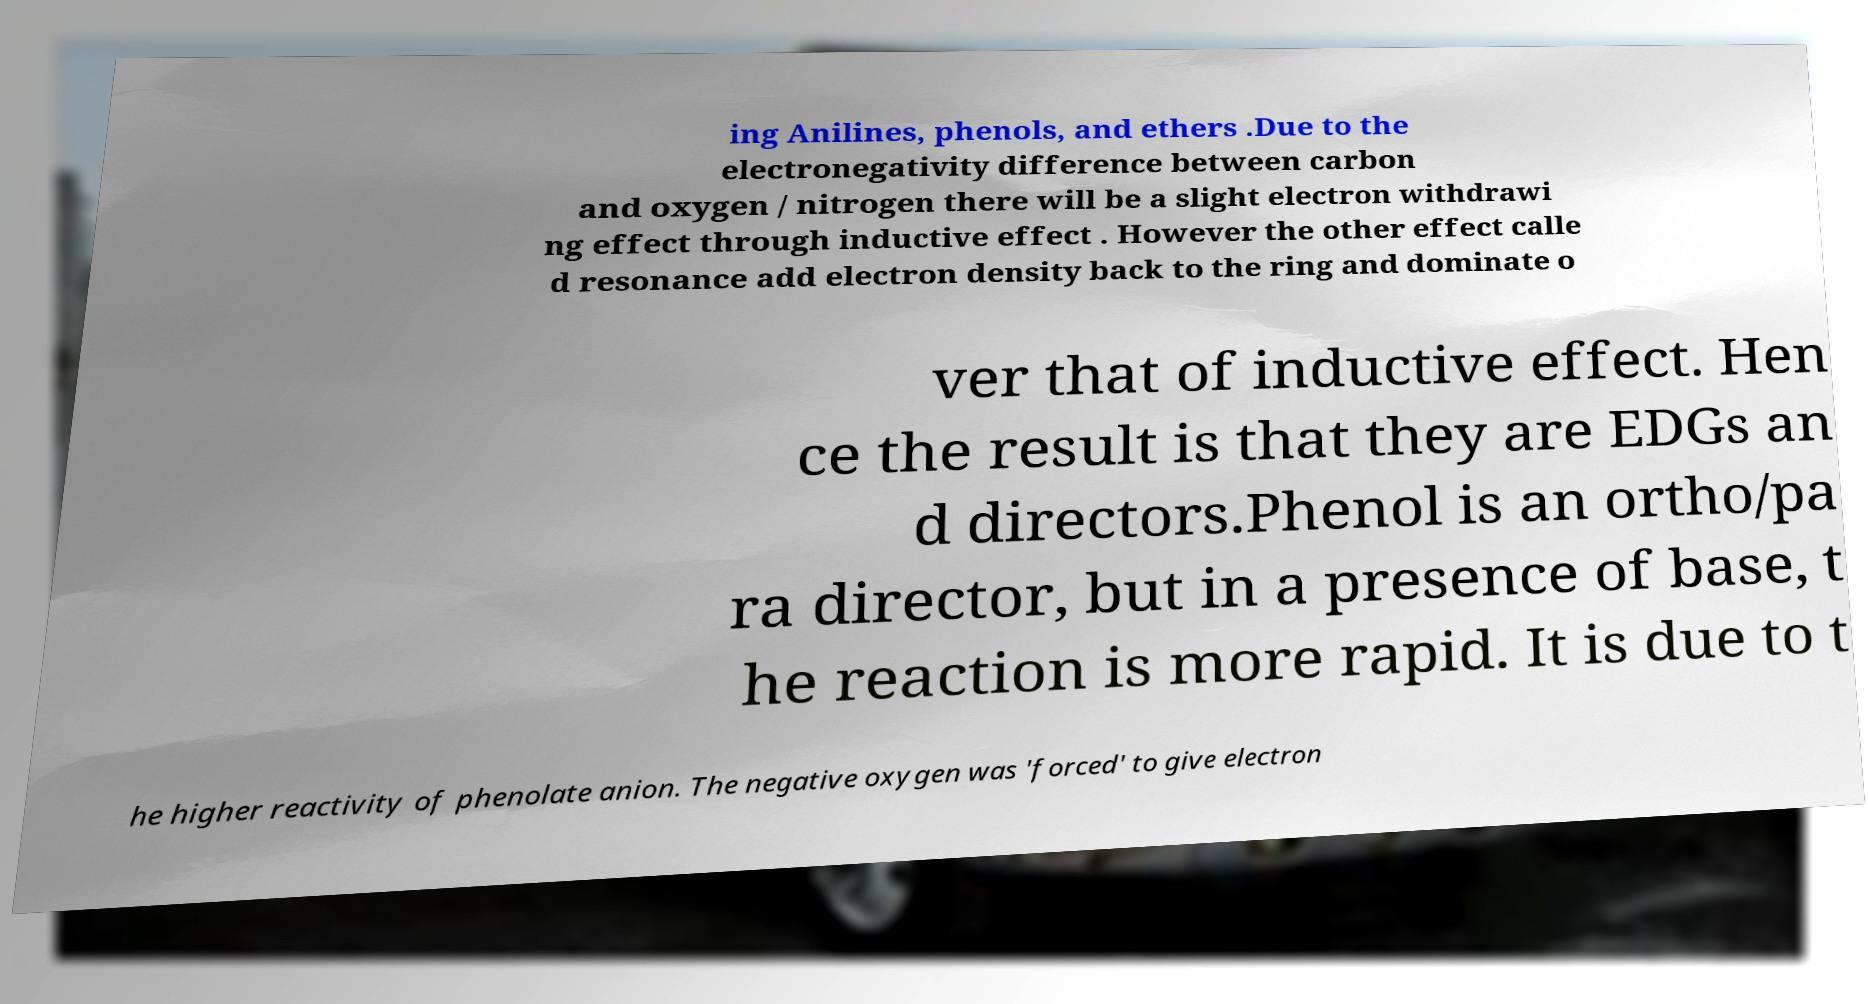Please read and relay the text visible in this image. What does it say? ing Anilines, phenols, and ethers .Due to the electronegativity difference between carbon and oxygen / nitrogen there will be a slight electron withdrawi ng effect through inductive effect . However the other effect calle d resonance add electron density back to the ring and dominate o ver that of inductive effect. Hen ce the result is that they are EDGs an d directors.Phenol is an ortho/pa ra director, but in a presence of base, t he reaction is more rapid. It is due to t he higher reactivity of phenolate anion. The negative oxygen was 'forced' to give electron 